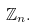<formula> <loc_0><loc_0><loc_500><loc_500>\mathbb { Z } _ { n } .</formula> 